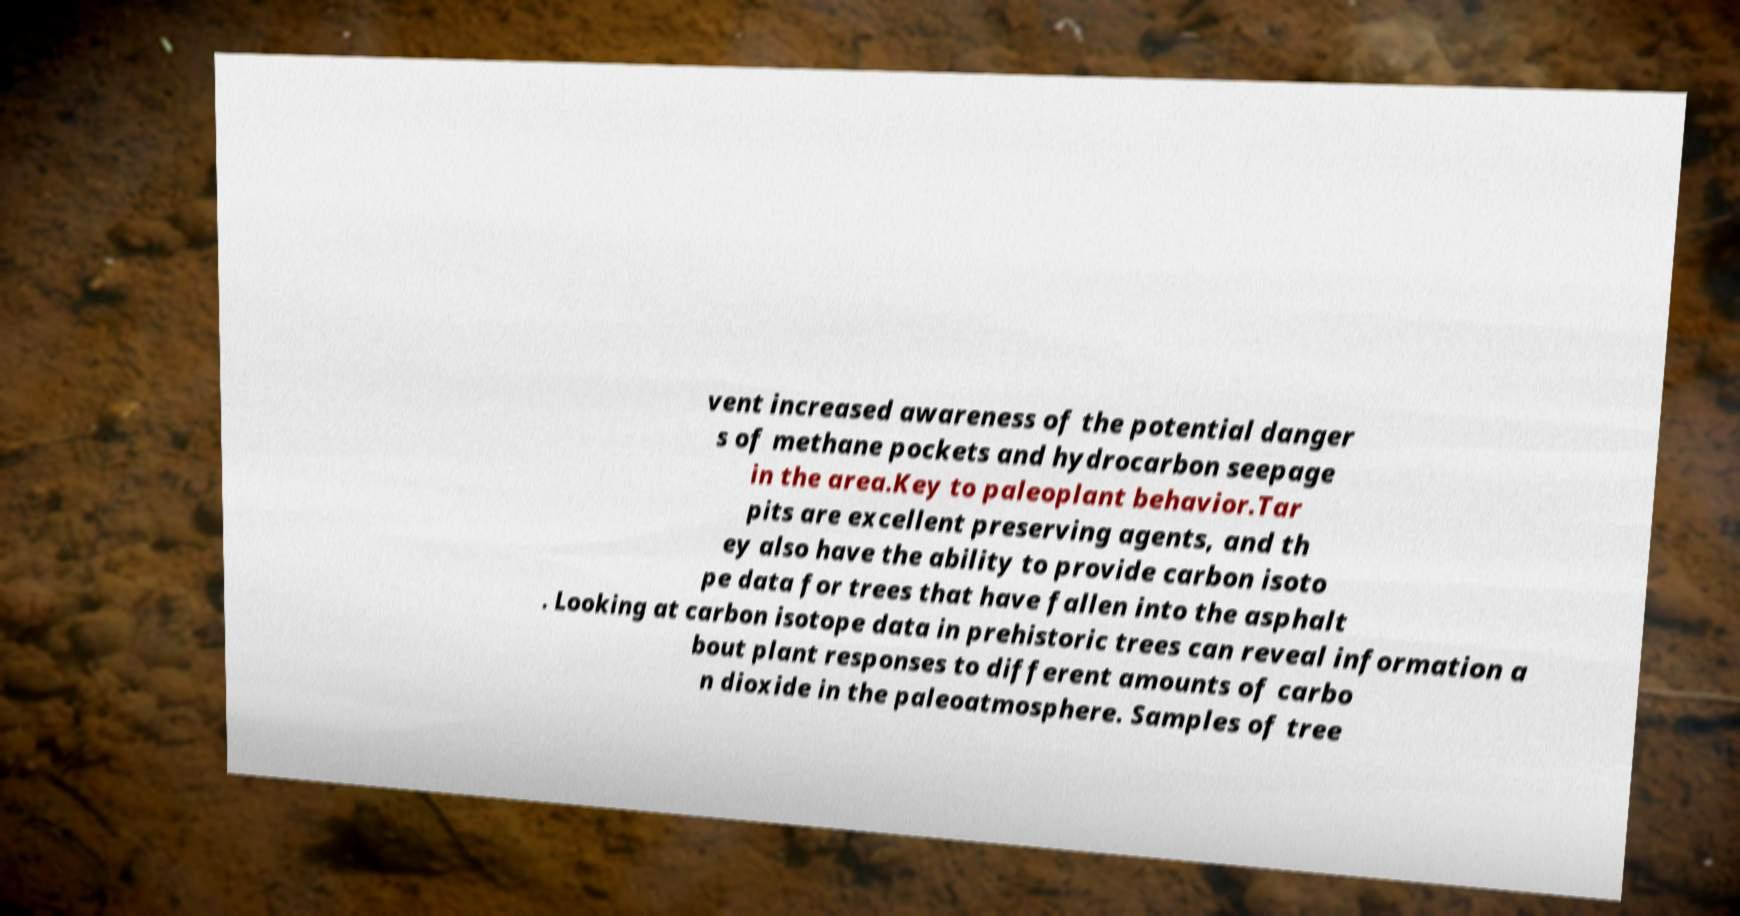Please read and relay the text visible in this image. What does it say? vent increased awareness of the potential danger s of methane pockets and hydrocarbon seepage in the area.Key to paleoplant behavior.Tar pits are excellent preserving agents, and th ey also have the ability to provide carbon isoto pe data for trees that have fallen into the asphalt . Looking at carbon isotope data in prehistoric trees can reveal information a bout plant responses to different amounts of carbo n dioxide in the paleoatmosphere. Samples of tree 